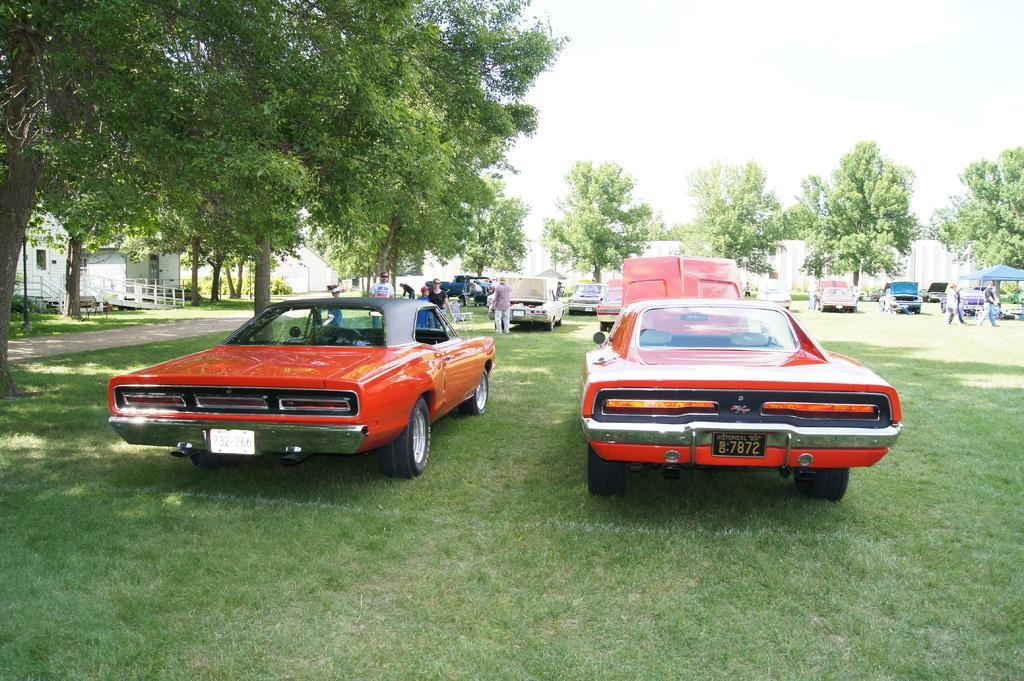Could you give a brief overview of what you see in this image? In this image, in the middle, we can see two cars which are in red color and the cars are placed on the grass. On the right side, we can see a group of people, cars, tent, trees. On the left side, we can also see some trees, house, staircase. In the background, we can see a group of people, cars, trees. At the top, we can see a sky, at the bottom, we can see a grass and a road. 